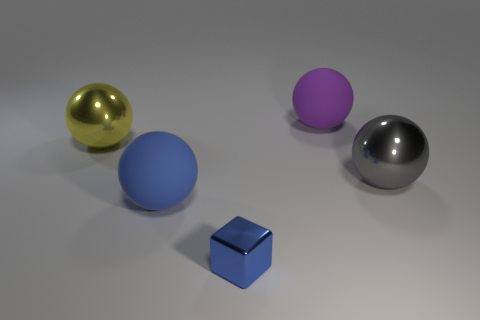There is a large metal object that is to the left of the large metal ball in front of the big yellow metallic sphere; how many big spheres are on the right side of it?
Your answer should be compact. 3. What number of large things are blue rubber balls or shiny things?
Provide a succinct answer. 3. Does the sphere in front of the large gray shiny sphere have the same material as the big gray sphere?
Provide a succinct answer. No. What material is the blue object that is behind the metallic block that is in front of the large shiny sphere that is left of the large blue rubber sphere?
Offer a very short reply. Rubber. Is there anything else that has the same size as the blue ball?
Make the answer very short. Yes. How many metal things are large gray objects or blocks?
Provide a short and direct response. 2. Is there a cyan matte cube?
Your response must be concise. No. There is a large metallic object on the left side of the big matte ball on the left side of the cube; what is its color?
Keep it short and to the point. Yellow. What number of other things are the same color as the small metallic block?
Make the answer very short. 1. How many things are either blue matte balls or big spheres that are in front of the purple thing?
Your answer should be compact. 3. 